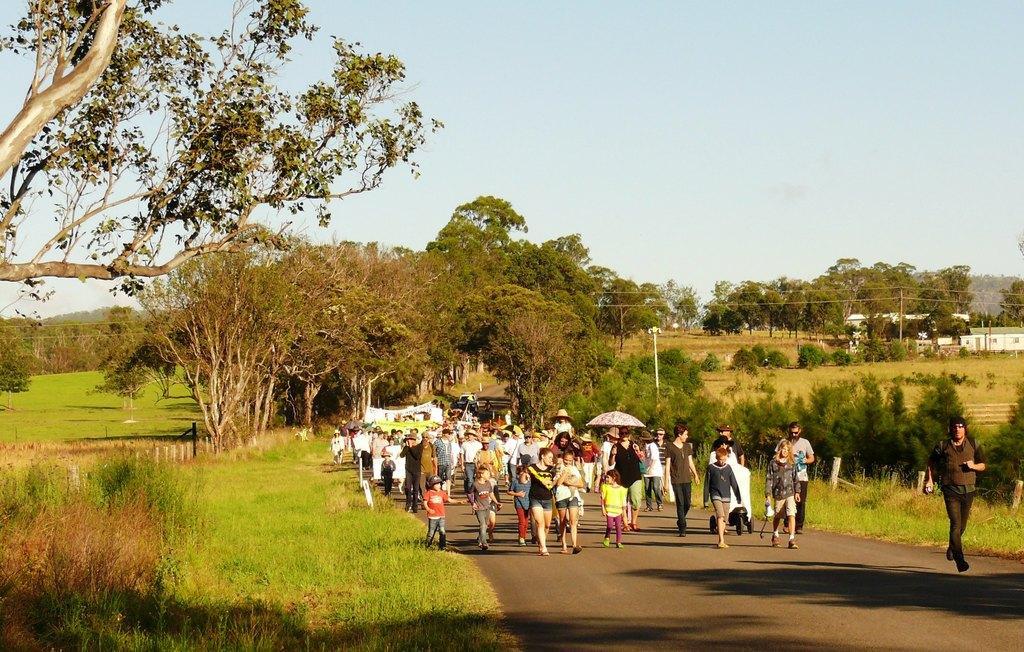In one or two sentences, can you explain what this image depicts? In the picture we can see a road on it, we can see people are walking and coming and one person is holding an umbrella and beside the road we can see grass surface and plants and in the background, we can see, full of trees and behind it we can see some poles with wires and some house near it and behind it we can see a sky. 